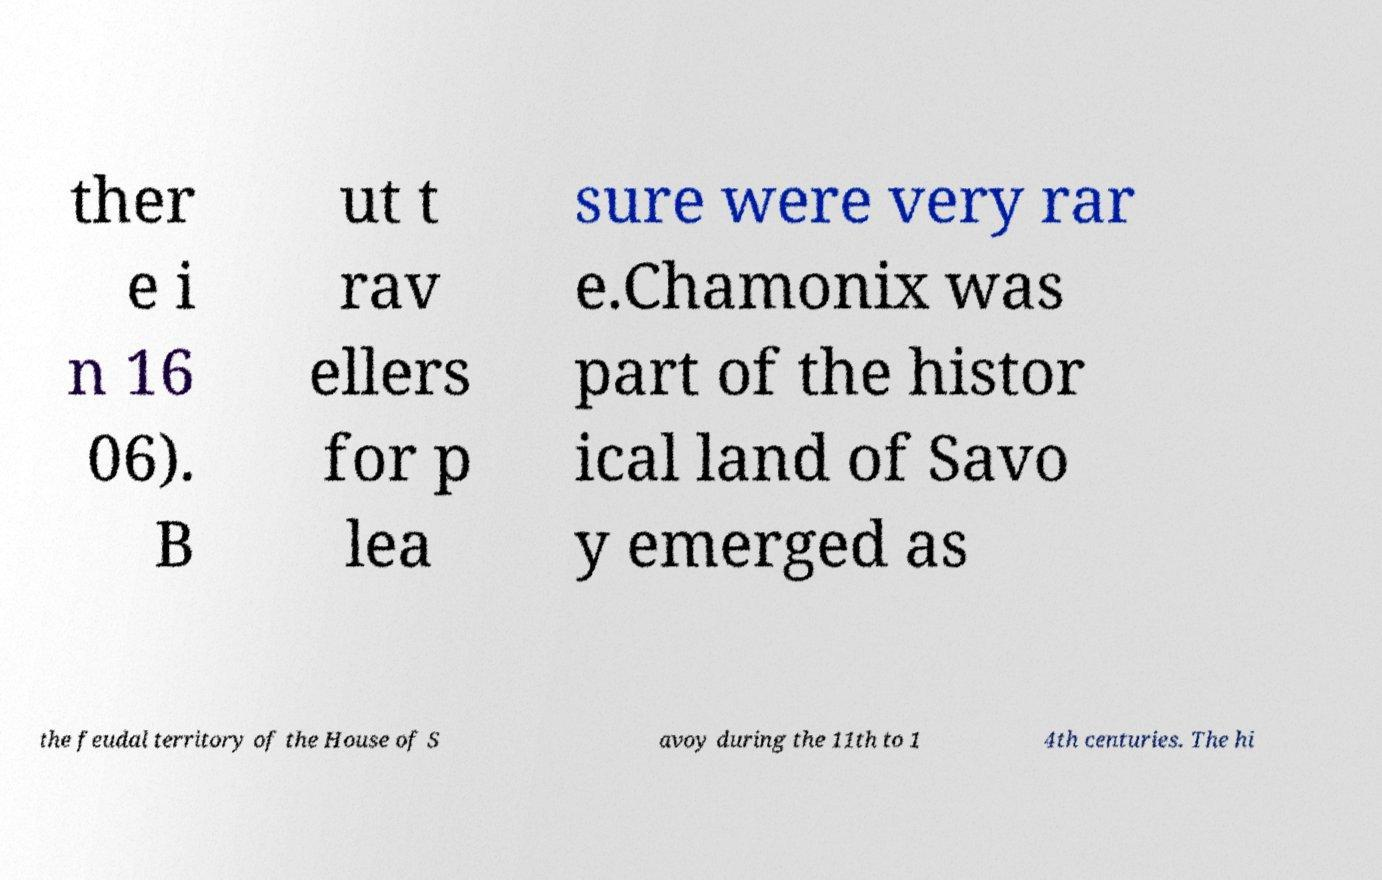For documentation purposes, I need the text within this image transcribed. Could you provide that? ther e i n 16 06). B ut t rav ellers for p lea sure were very rar e.Chamonix was part of the histor ical land of Savo y emerged as the feudal territory of the House of S avoy during the 11th to 1 4th centuries. The hi 